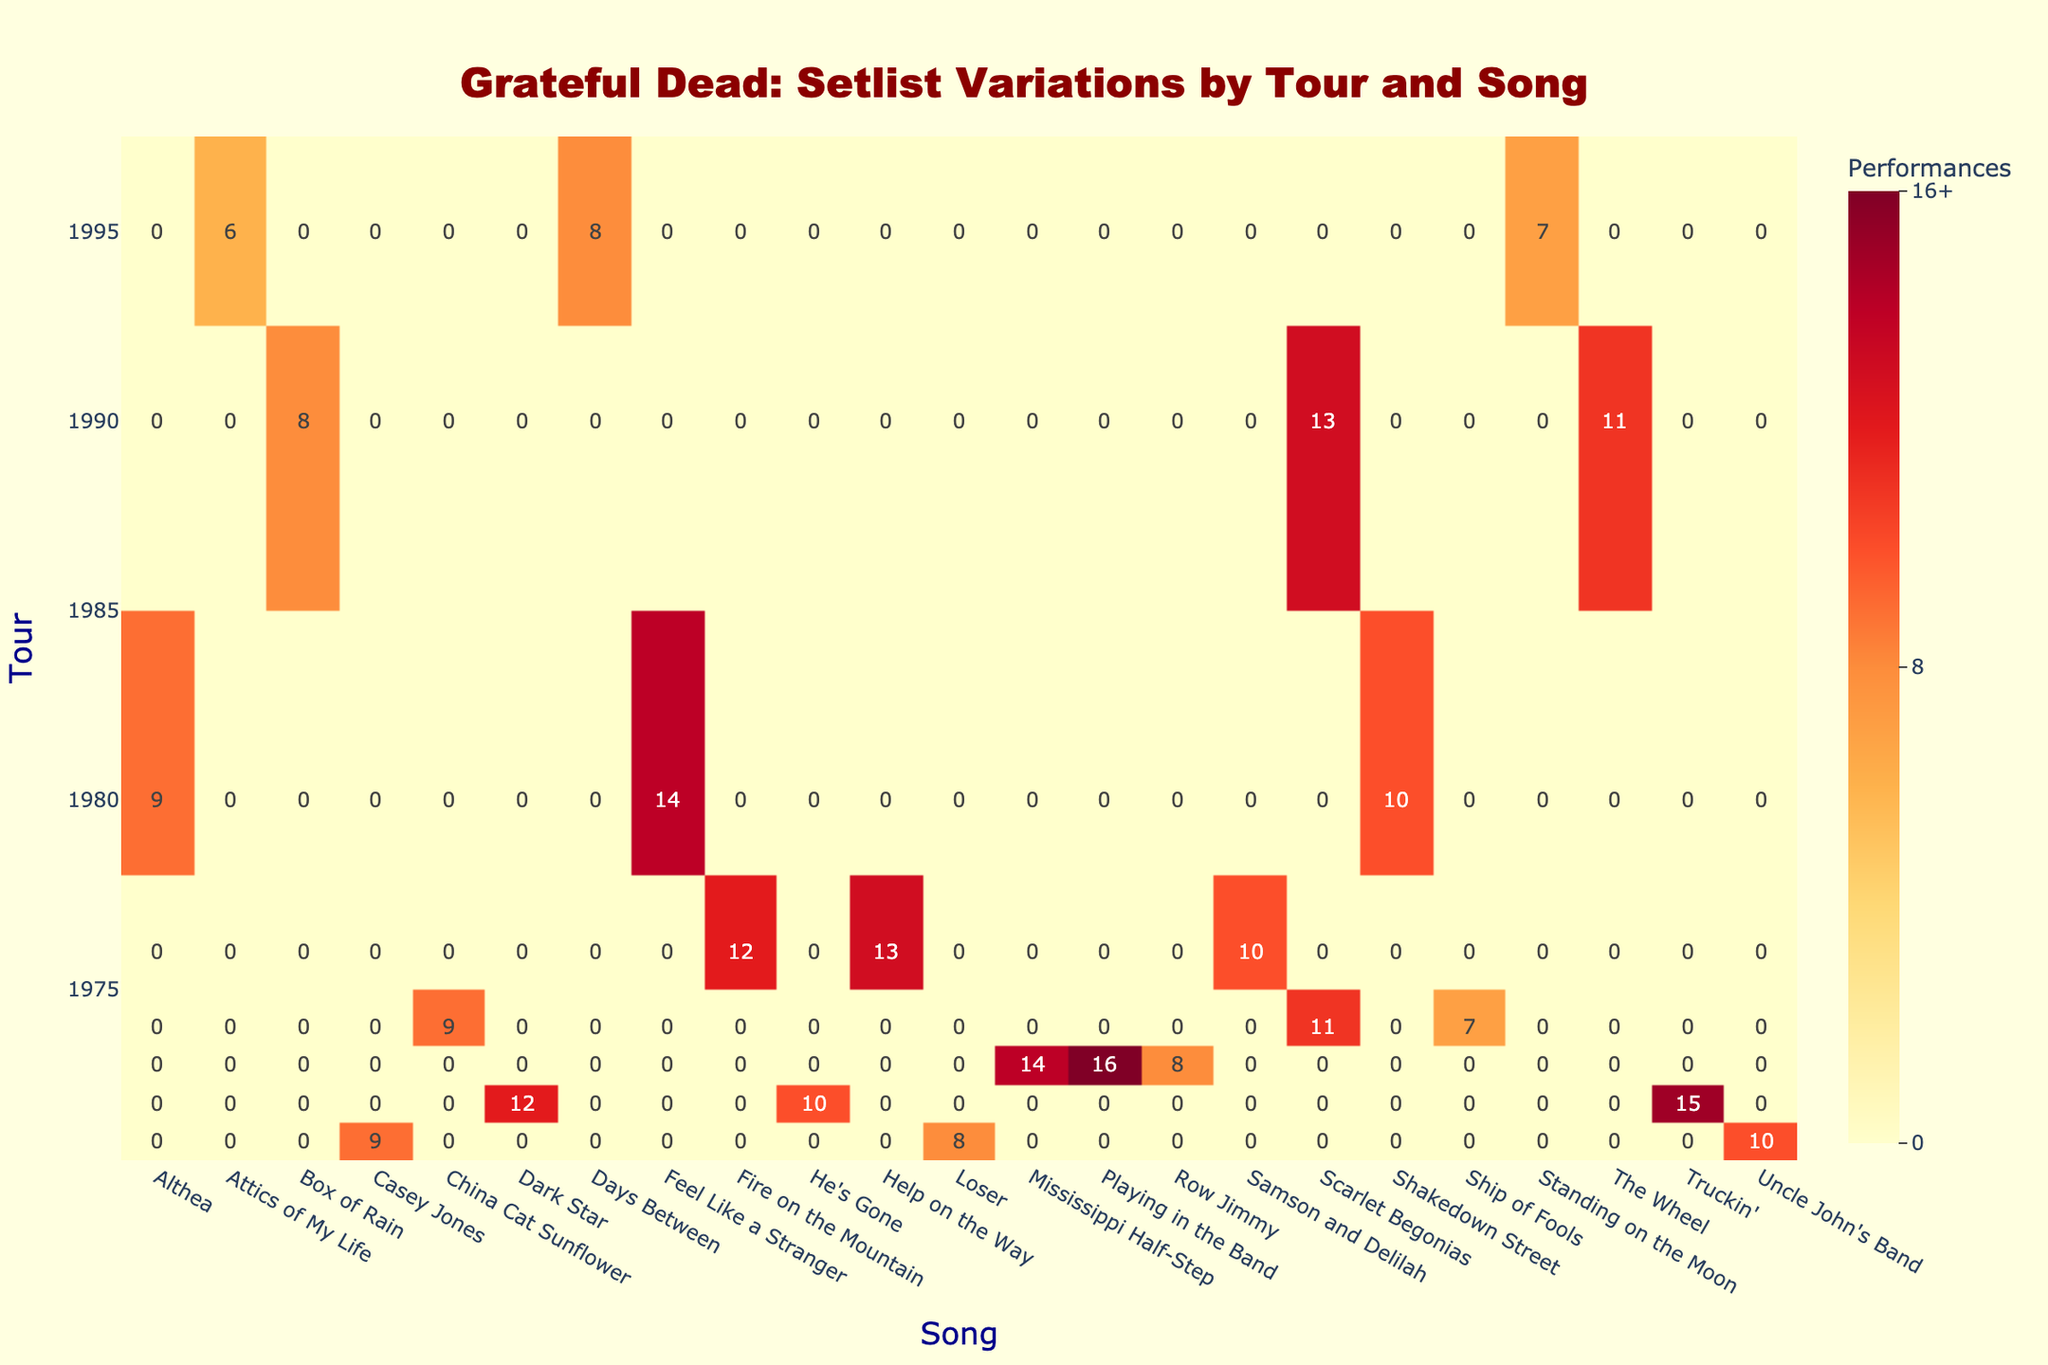What song had the highest number of performances in the 1972 tour? In the 1972 tour, the song with the highest number of performances is "Truckin'," which had 15 performances.
Answer: Truckin' How many times was "Scarlet Begonias" performed across all tours? "Scarlet Begonias" was performed in the 1974 tour (11 performances) and the 1990 tour (13 performances). Adding these gives a total of 11 + 13 = 24 performances.
Answer: 24 Which tour had the least number of song performances overall? The 1995 tour has the least number of performances, with a total of 21 performances (7 + 8 + 6).
Answer: 1995 Did "Casey Jones" ever have more performances than "He's Gone"? Yes, "Casey Jones" was performed 9 times in 1971, while "He's Gone" was performed 10 times in 1972. Therefore, "Casey Jones" did not have more performances than "He's Gone."
Answer: No What is the average number of performances for songs in the 1973 tour? The songs in the 1973 tour are "Mississippi Half-Step" (14), "Row Jimmy" (8), and "Playing in the Band" (16). The sum of performances is 14 + 8 + 16 = 38. There are 3 songs, so the average is 38 / 3 = 12.67.
Answer: 12.67 Which song was performed more often in the 1980 tour, "Althea" or "Feel Like a Stranger"? In the 1980 tour, "Feel Like a Stranger" was performed 14 times, while "Althea" was performed 9 times. Since 14 is greater than 9, "Feel Like a Stranger" was performed more often.
Answer: Feel Like a Stranger How many songs were performed in both 1971 and 1974 tours? The unique songs performed in the 1971 tour are "Casey Jones," "Loser," and "Uncle John's Band." In the 1974 tour, "Scarlet Begonias," "China Cat Sunflower," and "Ship of Fools" were performed. There are no songs that were performed in both tours.
Answer: 0 In which year did the song "Shakedown Street" see the most performances? "Shakedown Street" was performed only in the 1980 tour, with 10 performances, so that is the only year it appeared, marking it as the year it saw the most performances.
Answer: 1980 Was "Days Between" performed more times than "Attics of My Life" in the 1995 tour? "Days Between" was performed 8 times and "Attics of My Life" was performed 6 times in the 1995 tour. Since 8 is greater than 6, "Days Between" was performed more times.
Answer: Yes Can you identify a song that was performed in 1976 but not in 1974? In the 1976 tour, the songs performed include "Samson and Delilah," "Help on the Way," and "Fire on the Mountain." None of these songs were performed in the 1974 tour, which featured different songs. Thus, all of them fit this criterion.
Answer: Samson and Delilah, Help on the Way, Fire on the Mountain 